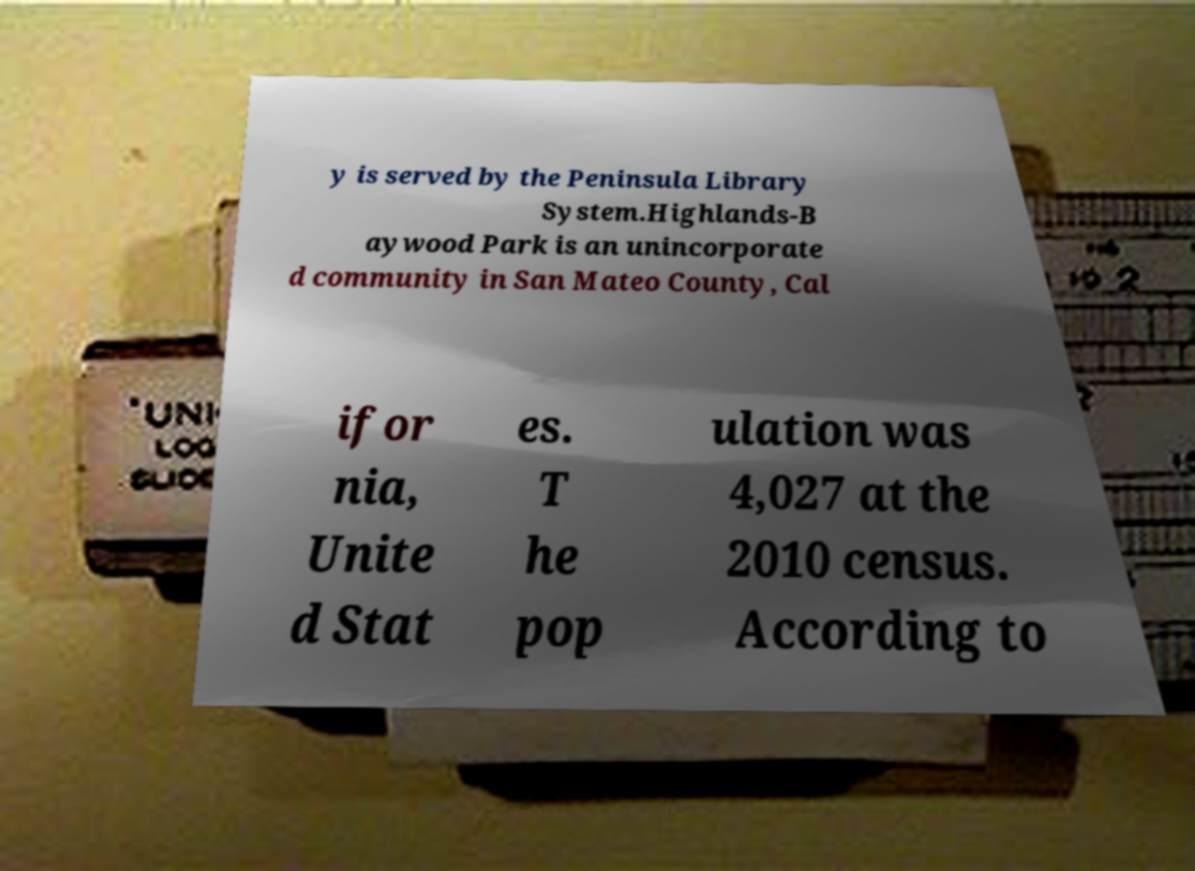Please read and relay the text visible in this image. What does it say? y is served by the Peninsula Library System.Highlands-B aywood Park is an unincorporate d community in San Mateo County, Cal ifor nia, Unite d Stat es. T he pop ulation was 4,027 at the 2010 census. According to 